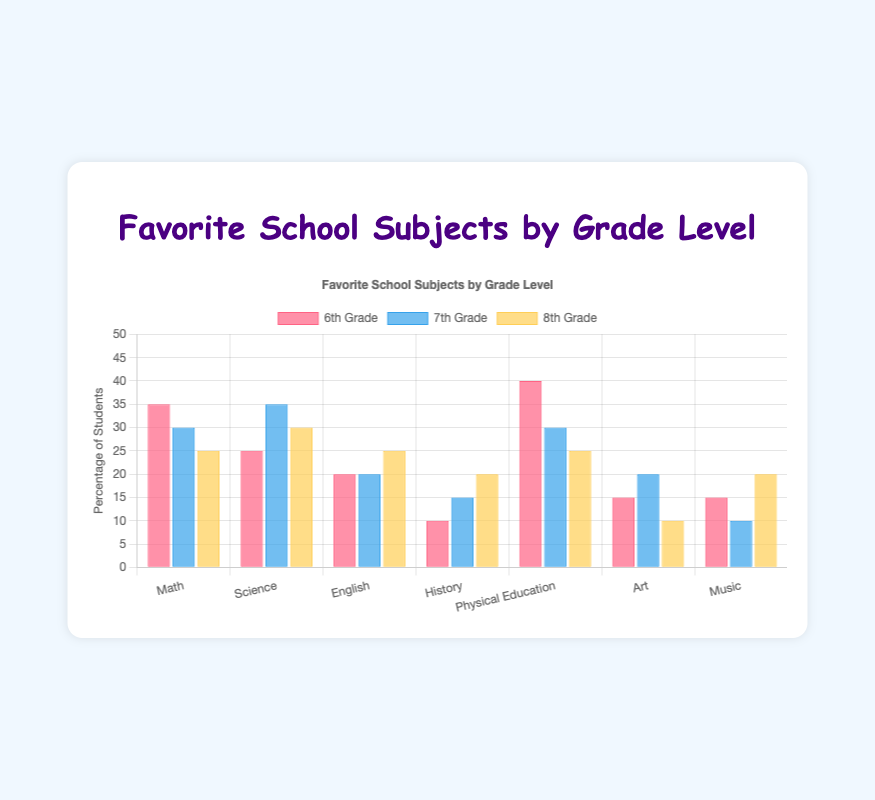Which grade level has the highest percentage of students who prefer Math? By looking at the bars labeled "Math," we can observe the heights of the bars for each grade level. The highest bar represents 6th Grade with 35%.
Answer: 6th Grade How many more percentage points do 6th graders prefer Physical Education compared to 8th graders? Look at the "Physical Education" bars for both 6th and 8th grades. Subtract the percentage of 8th graders (25%) from the percentage of 6th graders (40%). \( 40\% - 25\% = 15\% \)
Answer: 15% Which subject has the least popularity among 7th graders? Observe the height of the bars for 7th Grade. The shortest bar represents Music with 10%.
Answer: Music In which grade level is Science the most favored subject? By comparing the heights of the "Science" bars, the tallest bar belongs to 7th Grade with 35%.
Answer: 7th Grade What is the average percentage of students who prefer English across all grade levels? Sum the percentages of English for all grades and divide by the number of grades: \( \frac{20\% + 20\% + 25\%}{3} = \frac{65}{3} \approx 21.67\% \)
Answer: 21.67% What is the combined percentage of students in 8th Grade who prefer Art and History? Sum the percentages of Art and History for 8th Grade: \( 10\% + 20\% = 30\% \)
Answer: 30% Which grade level has the least variation in the preferences for different subjects? Analyze the height differences of bars within each grade. The 8th Grade bars seem to be the most uniform, suggesting minimal variation.
Answer: 8th Grade Which subject shows an increasing trend in preference as grade level increases? Compare bars from left to right for each subject. "History" shows an increasing trend (10% in 6th, 15% in 7th, 20% in 8th).
Answer: History Compare the sum of percentages for Math and Science in 6th Grade with that of 7th Grade. Which is higher? For 6th Grade: \( 35\% + 25\% = 60\% \). For 7th Grade: \( 30\% + 35\% = 65\% \). 7th Grade has a higher combined percentage.
Answer: 7th Grade How does the popularity of Physical Education change from 6th Grade to 8th Grade? Observe the "Physical Education" bars. It decreases from 40% in 6th Grade to 30% in 7th Grade and then to 25% in 8th Grade.
Answer: Decreases 